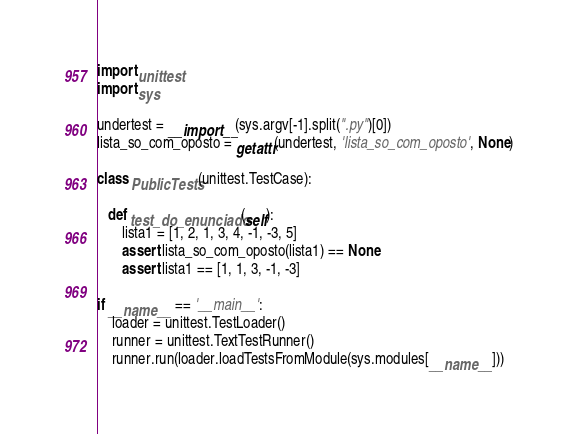<code> <loc_0><loc_0><loc_500><loc_500><_Python_>import unittest
import sys

undertest = __import__(sys.argv[-1].split(".py")[0])
lista_so_com_oposto = getattr(undertest, 'lista_so_com_oposto', None)

class PublicTests(unittest.TestCase):

   def test_do_enunciado(self):
       lista1 = [1, 2, 1, 3, 4, -1, -3, 5]
       assert lista_so_com_oposto(lista1) == None
       assert lista1 == [1, 1, 3, -1, -3]

if __name__ == '__main__':
    loader = unittest.TestLoader()
    runner = unittest.TextTestRunner()
    runner.run(loader.loadTestsFromModule(sys.modules[__name__]))
</code> 